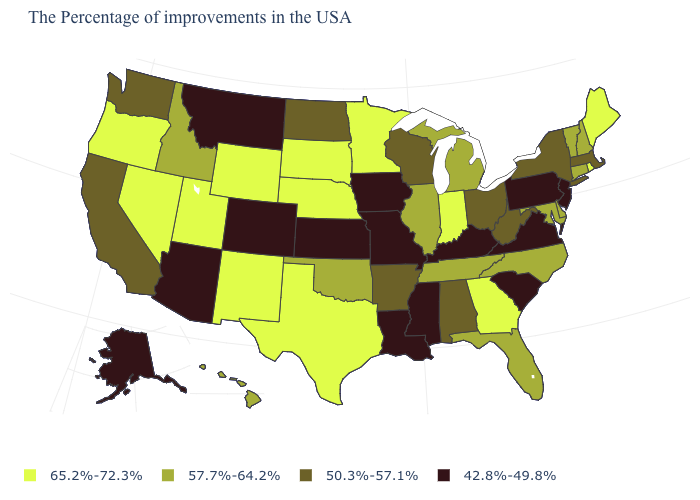Among the states that border California , which have the highest value?
Quick response, please. Nevada, Oregon. Which states hav the highest value in the MidWest?
Keep it brief. Indiana, Minnesota, Nebraska, South Dakota. Among the states that border North Dakota , does Montana have the lowest value?
Answer briefly. Yes. Among the states that border New Mexico , which have the lowest value?
Keep it brief. Colorado, Arizona. What is the value of Utah?
Keep it brief. 65.2%-72.3%. What is the value of Arkansas?
Quick response, please. 50.3%-57.1%. What is the value of Oregon?
Concise answer only. 65.2%-72.3%. How many symbols are there in the legend?
Concise answer only. 4. How many symbols are there in the legend?
Give a very brief answer. 4. Name the states that have a value in the range 57.7%-64.2%?
Give a very brief answer. New Hampshire, Vermont, Connecticut, Delaware, Maryland, North Carolina, Florida, Michigan, Tennessee, Illinois, Oklahoma, Idaho, Hawaii. Does Alaska have the lowest value in the USA?
Answer briefly. Yes. Name the states that have a value in the range 42.8%-49.8%?
Quick response, please. New Jersey, Pennsylvania, Virginia, South Carolina, Kentucky, Mississippi, Louisiana, Missouri, Iowa, Kansas, Colorado, Montana, Arizona, Alaska. Name the states that have a value in the range 65.2%-72.3%?
Write a very short answer. Maine, Rhode Island, Georgia, Indiana, Minnesota, Nebraska, Texas, South Dakota, Wyoming, New Mexico, Utah, Nevada, Oregon. Does Connecticut have a lower value than Wyoming?
Give a very brief answer. Yes. How many symbols are there in the legend?
Keep it brief. 4. 